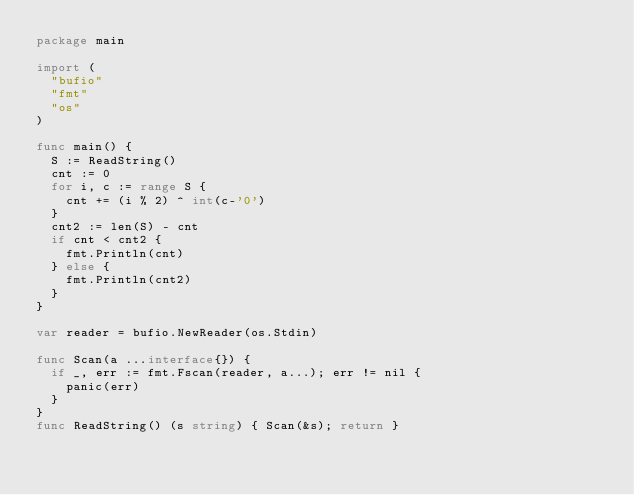<code> <loc_0><loc_0><loc_500><loc_500><_Go_>package main

import (
	"bufio"
	"fmt"
	"os"
)

func main() {
	S := ReadString()
	cnt := 0
	for i, c := range S {
		cnt += (i % 2) ^ int(c-'0')
	}
	cnt2 := len(S) - cnt
	if cnt < cnt2 {
		fmt.Println(cnt)
	} else {
		fmt.Println(cnt2)
	}
}

var reader = bufio.NewReader(os.Stdin)

func Scan(a ...interface{}) {
	if _, err := fmt.Fscan(reader, a...); err != nil {
		panic(err)
	}
}
func ReadString() (s string) { Scan(&s); return }
</code> 